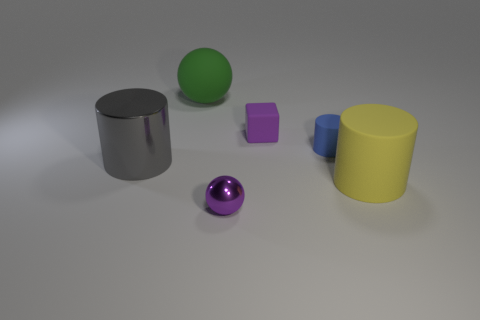What size is the object that is both left of the tiny shiny sphere and in front of the blue rubber thing?
Provide a short and direct response. Large. Does the shiny thing in front of the big yellow rubber cylinder have the same shape as the blue thing?
Make the answer very short. No. There is a sphere right of the sphere that is on the left side of the metal thing in front of the big shiny thing; what size is it?
Your response must be concise. Small. What size is the metallic thing that is the same color as the rubber cube?
Give a very brief answer. Small. How many objects are either yellow rubber cylinders or big gray metallic cylinders?
Provide a succinct answer. 2. What shape is the object that is on the left side of the tiny purple rubber thing and behind the tiny blue rubber object?
Ensure brevity in your answer.  Sphere. There is a purple metal thing; does it have the same shape as the large gray metal thing left of the small metal thing?
Your response must be concise. No. Are there any gray objects to the left of the tiny purple shiny thing?
Give a very brief answer. Yes. There is a tiny object that is the same color as the rubber block; what is it made of?
Make the answer very short. Metal. How many cubes are either big purple matte objects or large matte objects?
Ensure brevity in your answer.  0. 